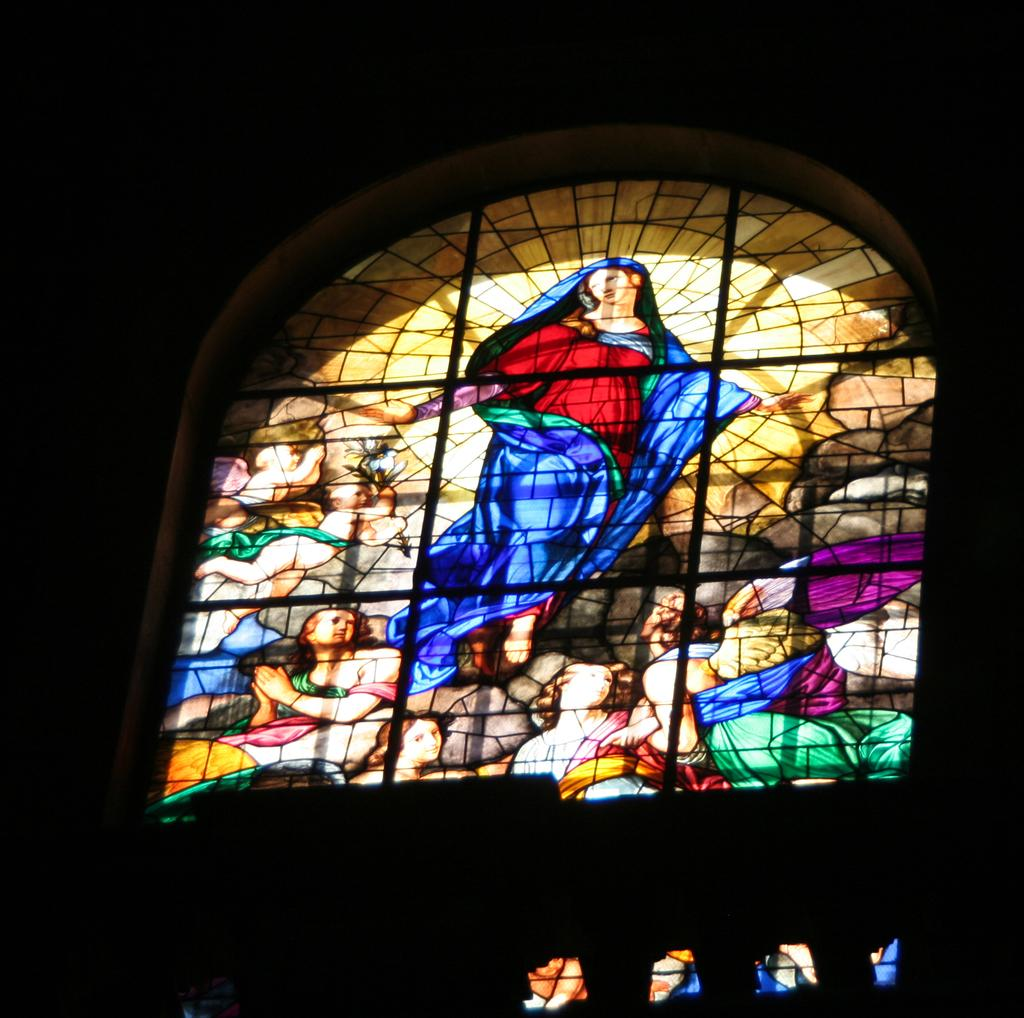What can be seen in the image that provides a view or access to the outdoors? There is a window in the image. What is added to the window to enhance its appearance or function? There are paintings on the window. What type of ink is used to create the paintings on the window? There is no information provided about the type of ink used for the paintings on the window. 